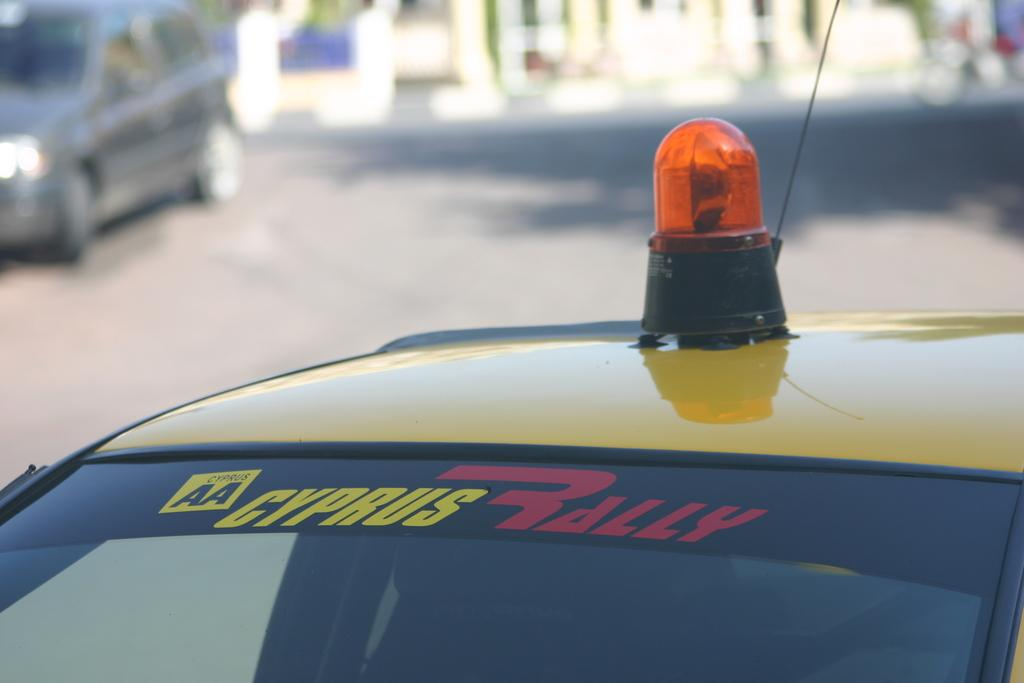<image>
Create a compact narrative representing the image presented. Top of the AA Cyprus Rally Car that has a light on the top of the car. 